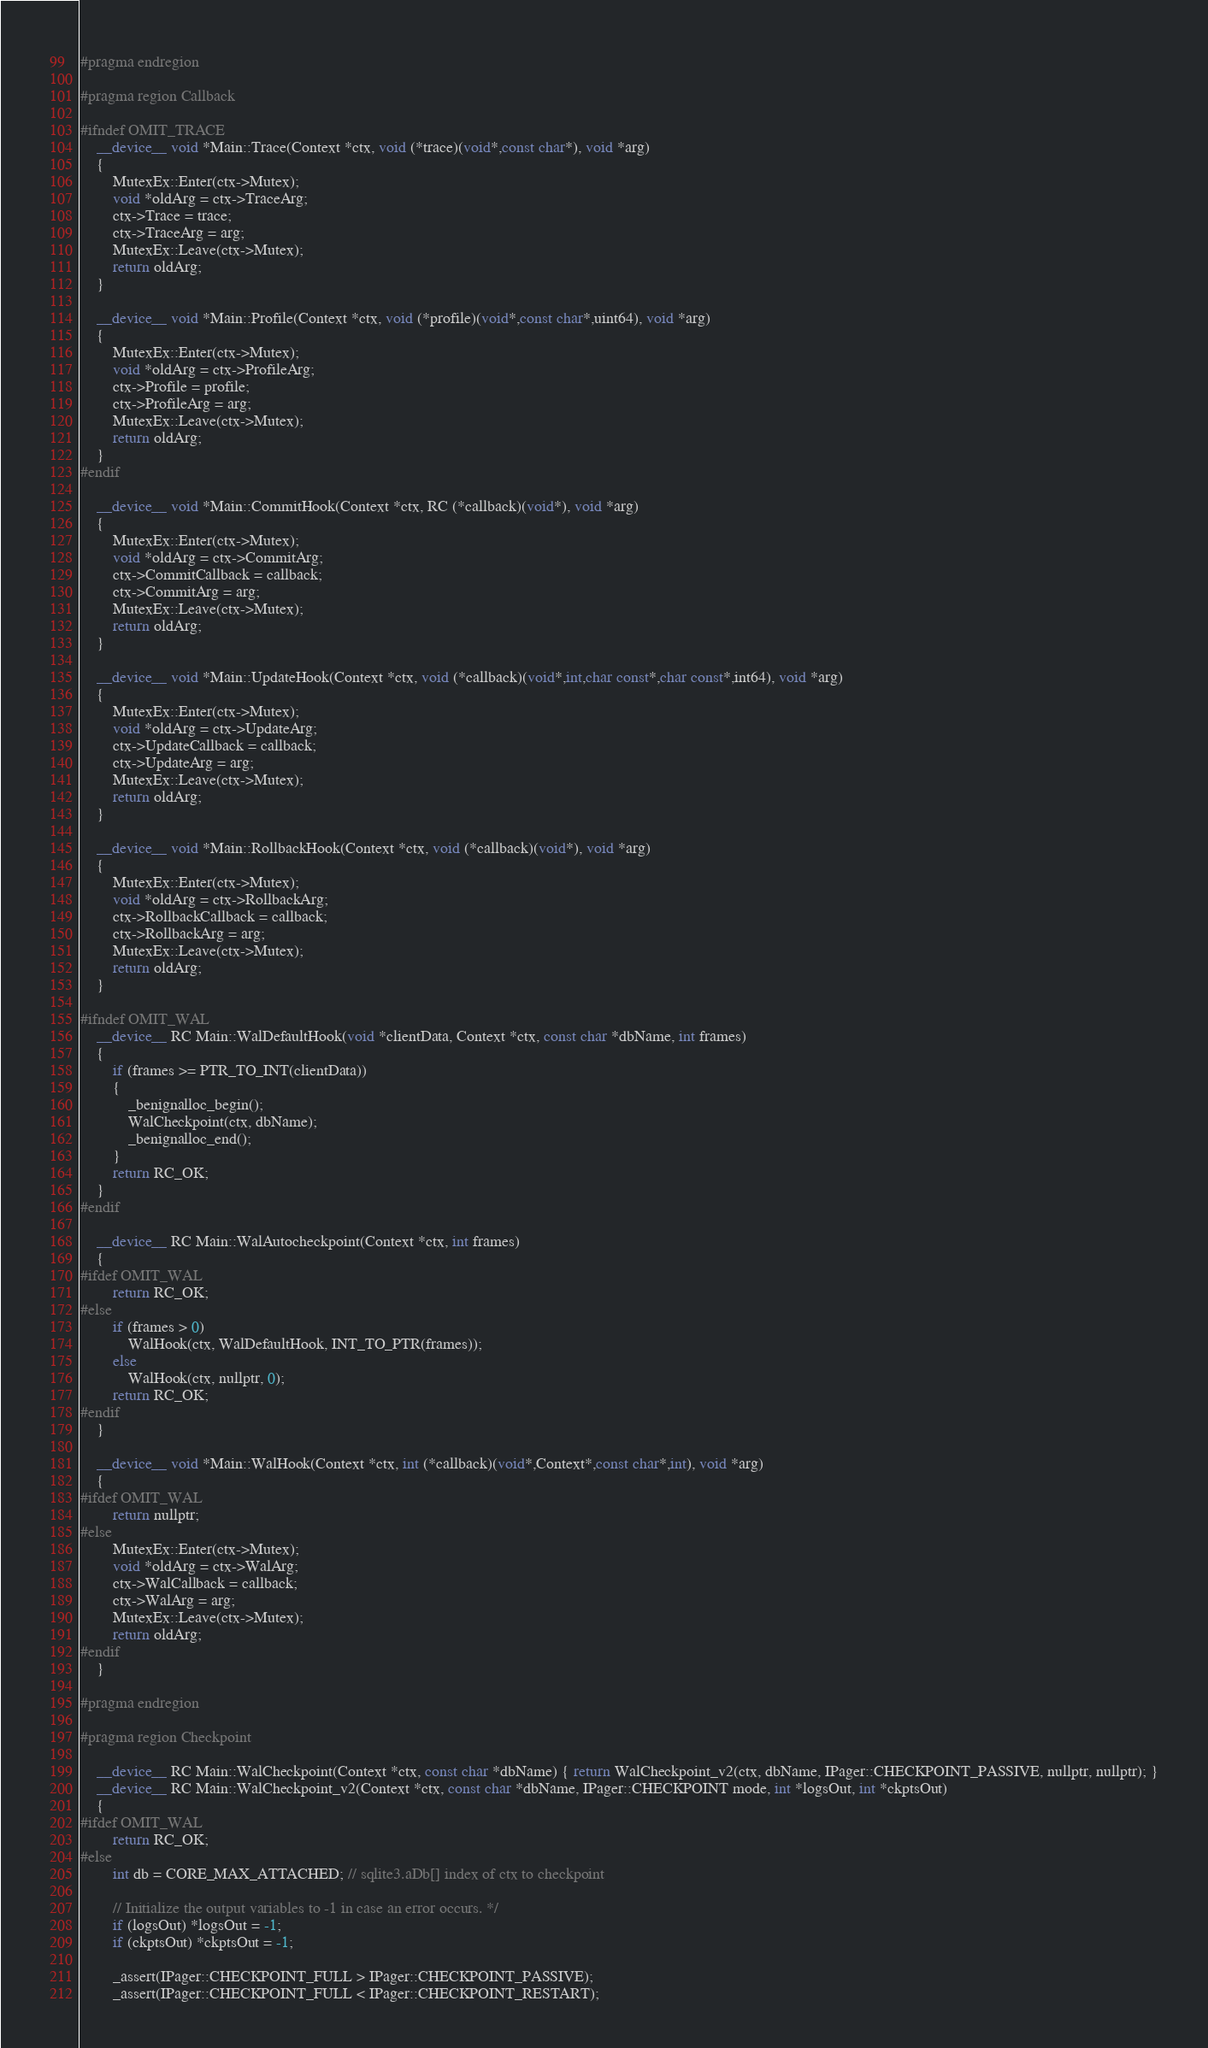Convert code to text. <code><loc_0><loc_0><loc_500><loc_500><_Cuda_>#pragma endregion

#pragma region Callback

#ifndef OMIT_TRACE
	__device__ void *Main::Trace(Context *ctx, void (*trace)(void*,const char*), void *arg)
	{
		MutexEx::Enter(ctx->Mutex);
		void *oldArg = ctx->TraceArg;
		ctx->Trace = trace;
		ctx->TraceArg = arg;
		MutexEx::Leave(ctx->Mutex);
		return oldArg;
	}

	__device__ void *Main::Profile(Context *ctx, void (*profile)(void*,const char*,uint64), void *arg)
	{
		MutexEx::Enter(ctx->Mutex);
		void *oldArg = ctx->ProfileArg;
		ctx->Profile = profile;
		ctx->ProfileArg = arg;
		MutexEx::Leave(ctx->Mutex);
		return oldArg;
	}
#endif

	__device__ void *Main::CommitHook(Context *ctx, RC (*callback)(void*), void *arg)
	{
		MutexEx::Enter(ctx->Mutex);
		void *oldArg = ctx->CommitArg;
		ctx->CommitCallback = callback;
		ctx->CommitArg = arg;
		MutexEx::Leave(ctx->Mutex);
		return oldArg;
	}

	__device__ void *Main::UpdateHook(Context *ctx, void (*callback)(void*,int,char const*,char const*,int64), void *arg)
	{
		MutexEx::Enter(ctx->Mutex);
		void *oldArg = ctx->UpdateArg;
		ctx->UpdateCallback = callback;
		ctx->UpdateArg = arg;
		MutexEx::Leave(ctx->Mutex);
		return oldArg;
	}

	__device__ void *Main::RollbackHook(Context *ctx, void (*callback)(void*), void *arg)
	{
		MutexEx::Enter(ctx->Mutex);
		void *oldArg = ctx->RollbackArg;
		ctx->RollbackCallback = callback;
		ctx->RollbackArg = arg;
		MutexEx::Leave(ctx->Mutex);
		return oldArg;
	}

#ifndef OMIT_WAL
	__device__ RC Main::WalDefaultHook(void *clientData, Context *ctx, const char *dbName, int frames)
	{
		if (frames >= PTR_TO_INT(clientData))
		{
			_benignalloc_begin();
			WalCheckpoint(ctx, dbName);
			_benignalloc_end();
		}
		return RC_OK;
	}
#endif

	__device__ RC Main::WalAutocheckpoint(Context *ctx, int frames)
	{
#ifdef OMIT_WAL
		return RC_OK;
#else
		if (frames > 0)
			WalHook(ctx, WalDefaultHook, INT_TO_PTR(frames));
		else
			WalHook(ctx, nullptr, 0);
		return RC_OK;
#endif
	}

	__device__ void *Main::WalHook(Context *ctx, int (*callback)(void*,Context*,const char*,int), void *arg)
	{
#ifdef OMIT_WAL
		return nullptr;
#else
		MutexEx::Enter(ctx->Mutex);
		void *oldArg = ctx->WalArg;
		ctx->WalCallback = callback;
		ctx->WalArg = arg;
		MutexEx::Leave(ctx->Mutex);
		return oldArg;
#endif
	}

#pragma endregion

#pragma region Checkpoint

	__device__ RC Main::WalCheckpoint(Context *ctx, const char *dbName) { return WalCheckpoint_v2(ctx, dbName, IPager::CHECKPOINT_PASSIVE, nullptr, nullptr); }
	__device__ RC Main::WalCheckpoint_v2(Context *ctx, const char *dbName, IPager::CHECKPOINT mode, int *logsOut, int *ckptsOut)
	{
#ifdef OMIT_WAL
		return RC_OK;
#else
		int db = CORE_MAX_ATTACHED; // sqlite3.aDb[] index of ctx to checkpoint

		// Initialize the output variables to -1 in case an error occurs. */
		if (logsOut) *logsOut = -1;
		if (ckptsOut) *ckptsOut = -1;

		_assert(IPager::CHECKPOINT_FULL > IPager::CHECKPOINT_PASSIVE);
		_assert(IPager::CHECKPOINT_FULL < IPager::CHECKPOINT_RESTART);</code> 